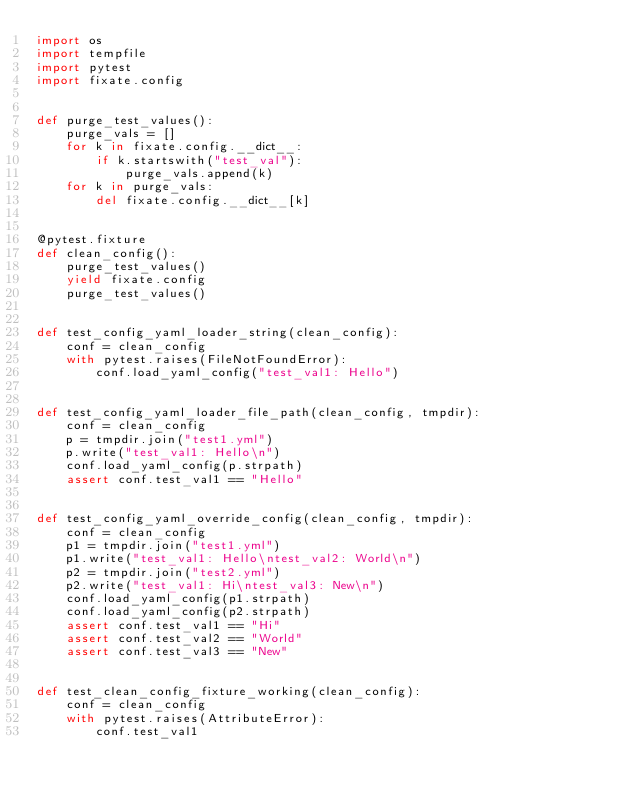<code> <loc_0><loc_0><loc_500><loc_500><_Python_>import os
import tempfile
import pytest
import fixate.config


def purge_test_values():
    purge_vals = []
    for k in fixate.config.__dict__:
        if k.startswith("test_val"):
            purge_vals.append(k)
    for k in purge_vals:
        del fixate.config.__dict__[k]


@pytest.fixture
def clean_config():
    purge_test_values()
    yield fixate.config
    purge_test_values()


def test_config_yaml_loader_string(clean_config):
    conf = clean_config
    with pytest.raises(FileNotFoundError):
        conf.load_yaml_config("test_val1: Hello")


def test_config_yaml_loader_file_path(clean_config, tmpdir):
    conf = clean_config
    p = tmpdir.join("test1.yml")
    p.write("test_val1: Hello\n")
    conf.load_yaml_config(p.strpath)
    assert conf.test_val1 == "Hello"


def test_config_yaml_override_config(clean_config, tmpdir):
    conf = clean_config
    p1 = tmpdir.join("test1.yml")
    p1.write("test_val1: Hello\ntest_val2: World\n")
    p2 = tmpdir.join("test2.yml")
    p2.write("test_val1: Hi\ntest_val3: New\n")
    conf.load_yaml_config(p1.strpath)
    conf.load_yaml_config(p2.strpath)
    assert conf.test_val1 == "Hi"
    assert conf.test_val2 == "World"
    assert conf.test_val3 == "New"


def test_clean_config_fixture_working(clean_config):
    conf = clean_config
    with pytest.raises(AttributeError):
        conf.test_val1
</code> 